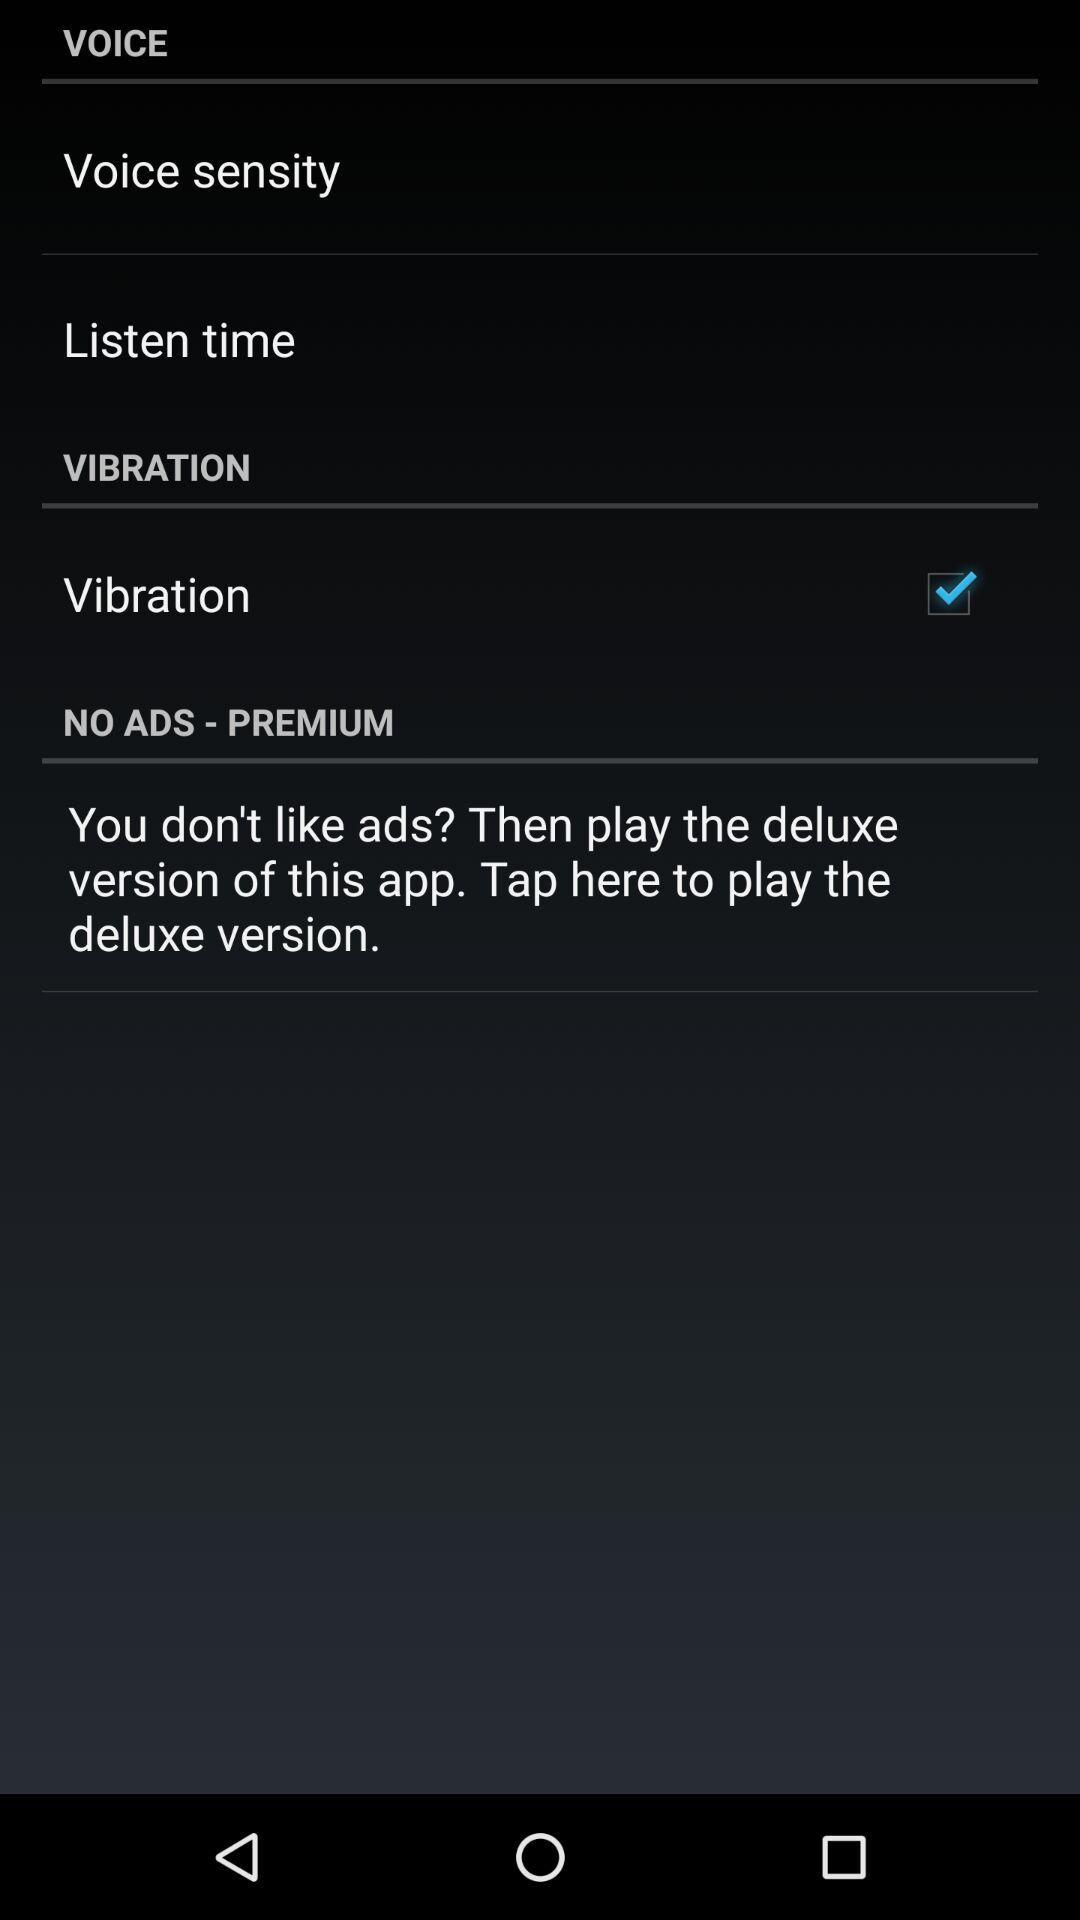Which option is checked? The checked option is "Vibration". 